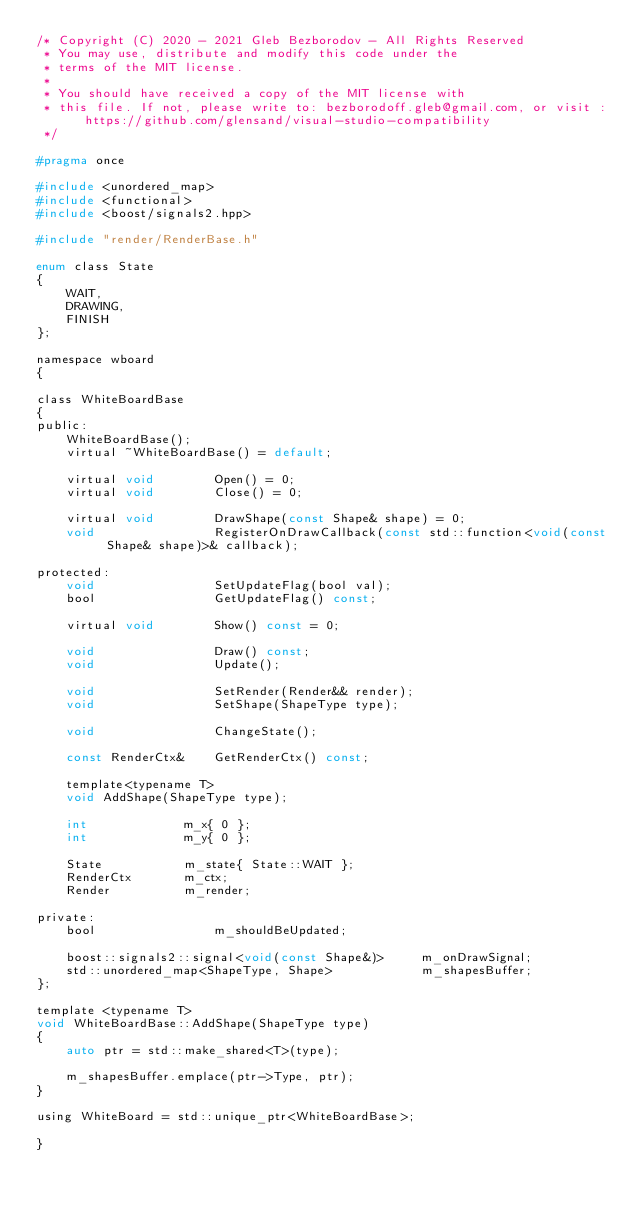<code> <loc_0><loc_0><loc_500><loc_500><_C_>/* Copyright (C) 2020 - 2021 Gleb Bezborodov - All Rights Reserved
 * You may use, distribute and modify this code under the
 * terms of the MIT license.
 *
 * You should have received a copy of the MIT license with
 * this file. If not, please write to: bezborodoff.gleb@gmail.com, or visit : https://github.com/glensand/visual-studio-compatibility
 */

#pragma once

#include <unordered_map>
#include <functional>
#include <boost/signals2.hpp>

#include "render/RenderBase.h"

enum class State
{
	WAIT,
	DRAWING,
	FINISH
};

namespace wboard
{
	
class WhiteBoardBase
{
public:
	WhiteBoardBase();
	virtual ~WhiteBoardBase() = default;

	virtual void		Open() = 0;
	virtual void		Close() = 0;

	virtual void		DrawShape(const Shape& shape) = 0;
	void				RegisterOnDrawCallback(const std::function<void(const Shape& shape)>& callback);
	
protected:
	void				SetUpdateFlag(bool val);
	bool				GetUpdateFlag() const;
	
	virtual void		Show() const = 0;
	
	void				Draw() const;
	void				Update();
	
	void				SetRender(Render&& render);
	void				SetShape(ShapeType type);
	
	void				ChangeState();
	
	const RenderCtx&	GetRenderCtx() const;

	template<typename T>
	void AddShape(ShapeType type);

	int				m_x{ 0 };
	int				m_y{ 0 };

	State			m_state{ State::WAIT };
	RenderCtx		m_ctx;
	Render			m_render;
	
private:
	bool				m_shouldBeUpdated;
	
	boost::signals2::signal<void(const Shape&)>		m_onDrawSignal;
	std::unordered_map<ShapeType, Shape>			m_shapesBuffer;
};

template <typename T>
void WhiteBoardBase::AddShape(ShapeType type)
{
	auto ptr = std::make_shared<T>(type);

	m_shapesBuffer.emplace(ptr->Type, ptr);
}

using WhiteBoard = std::unique_ptr<WhiteBoardBase>;

}

</code> 